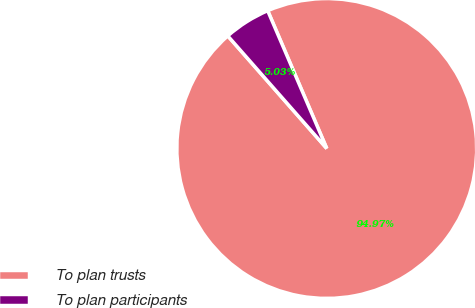Convert chart. <chart><loc_0><loc_0><loc_500><loc_500><pie_chart><fcel>To plan trusts<fcel>To plan participants<nl><fcel>94.97%<fcel>5.03%<nl></chart> 